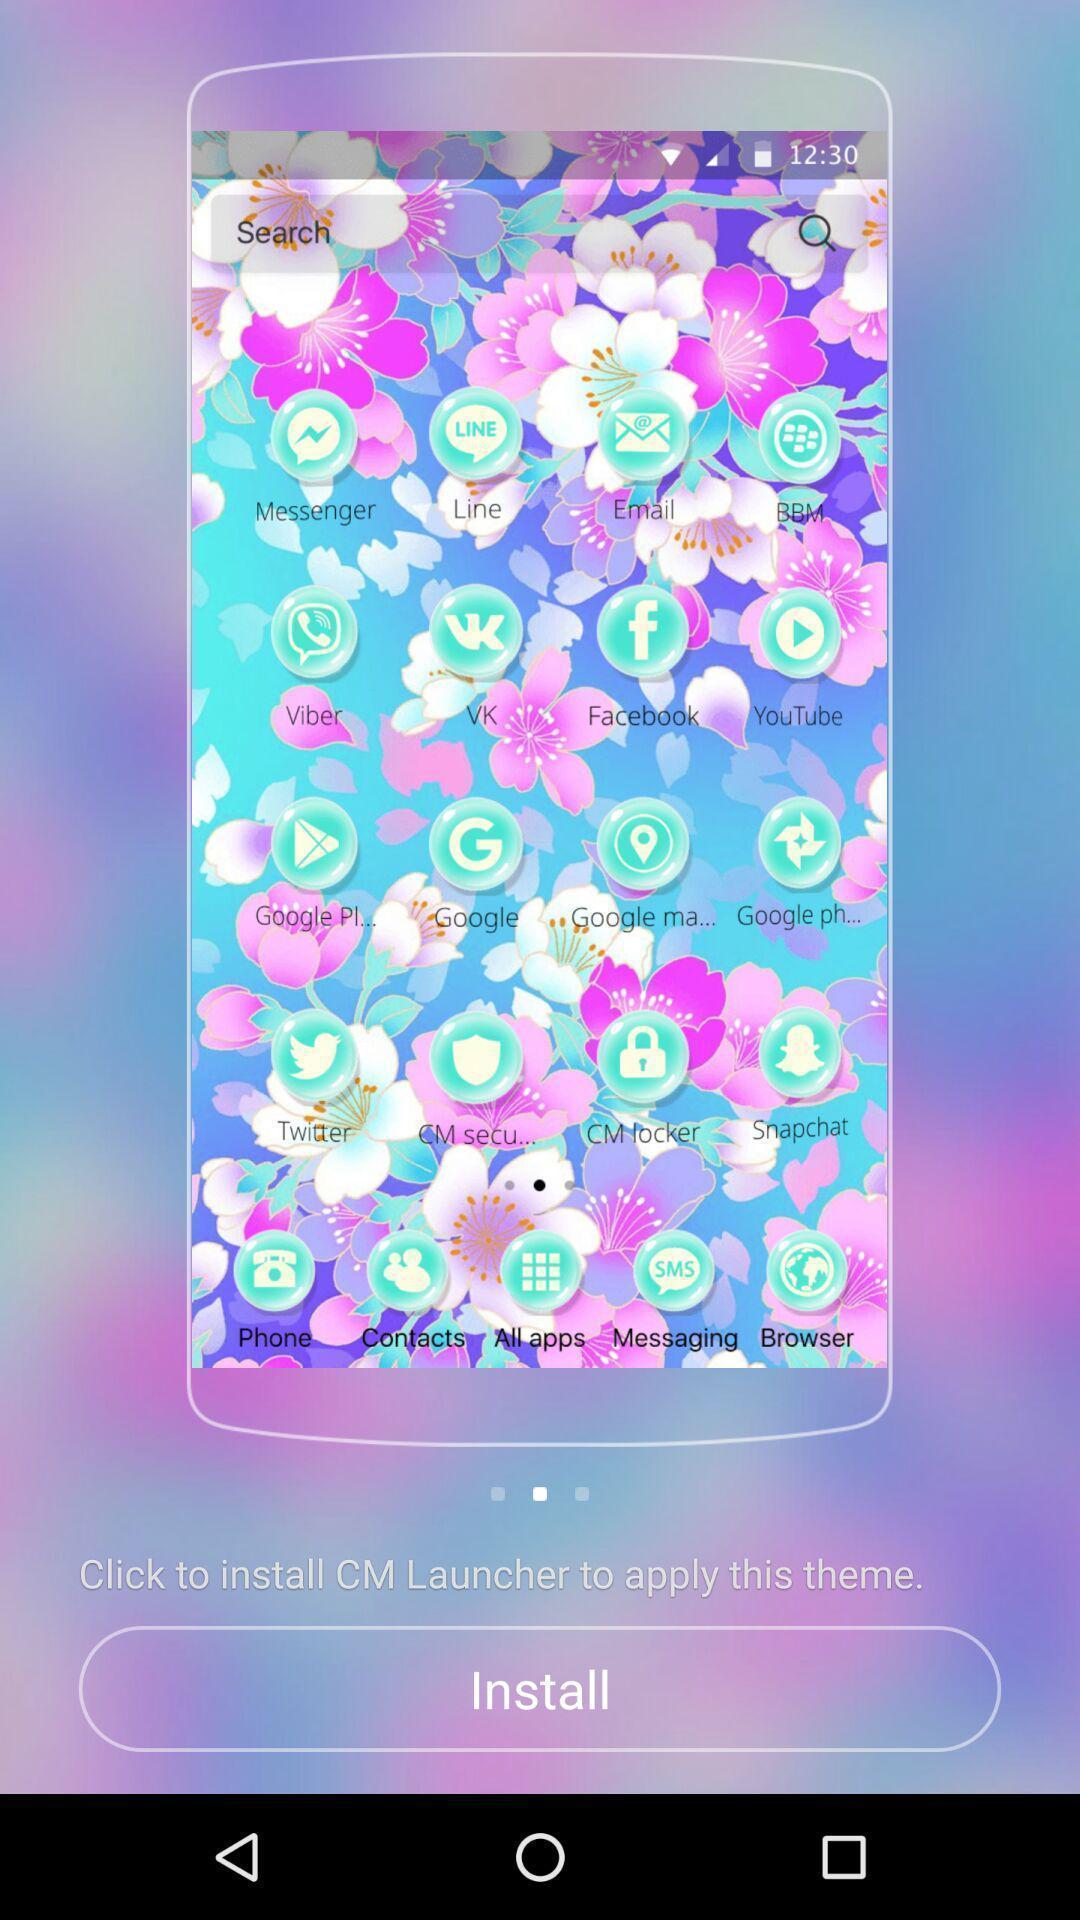Tell me about the visual elements in this screen capture. Screen shows to install a launcher. 